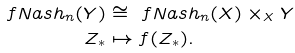Convert formula to latex. <formula><loc_0><loc_0><loc_500><loc_500>\ f N a s h _ { n } ( Y ) & \cong \ f N a s h _ { n } ( X ) \times _ { X } Y \\ Z _ { * } & \mapsto f ( Z _ { * } ) .</formula> 